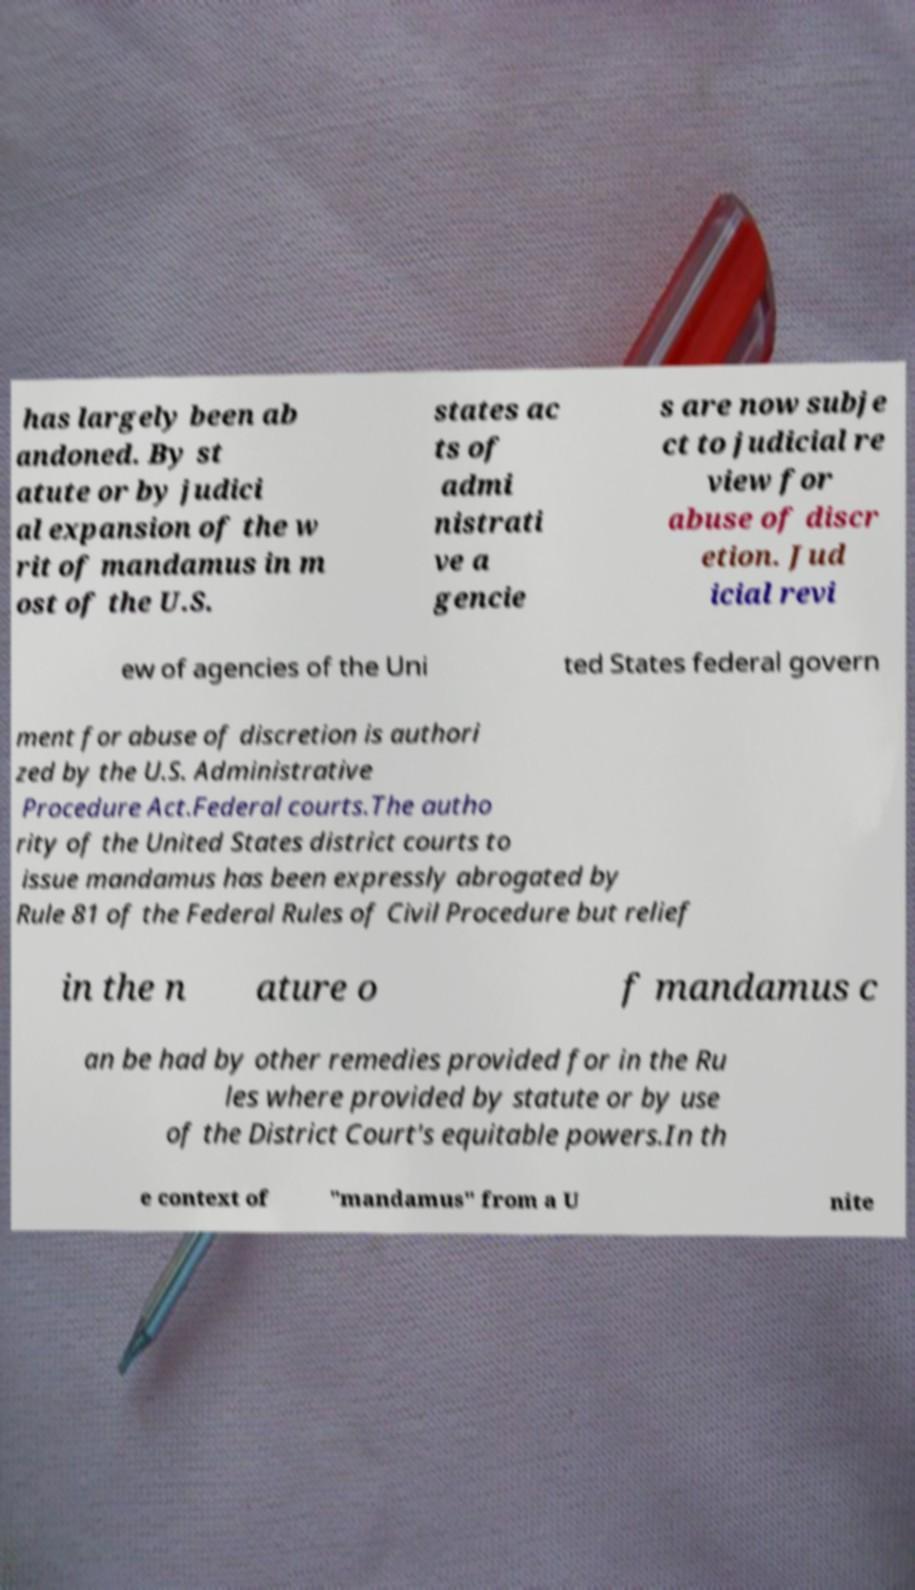Please identify and transcribe the text found in this image. has largely been ab andoned. By st atute or by judici al expansion of the w rit of mandamus in m ost of the U.S. states ac ts of admi nistrati ve a gencie s are now subje ct to judicial re view for abuse of discr etion. Jud icial revi ew of agencies of the Uni ted States federal govern ment for abuse of discretion is authori zed by the U.S. Administrative Procedure Act.Federal courts.The autho rity of the United States district courts to issue mandamus has been expressly abrogated by Rule 81 of the Federal Rules of Civil Procedure but relief in the n ature o f mandamus c an be had by other remedies provided for in the Ru les where provided by statute or by use of the District Court's equitable powers.In th e context of "mandamus" from a U nite 